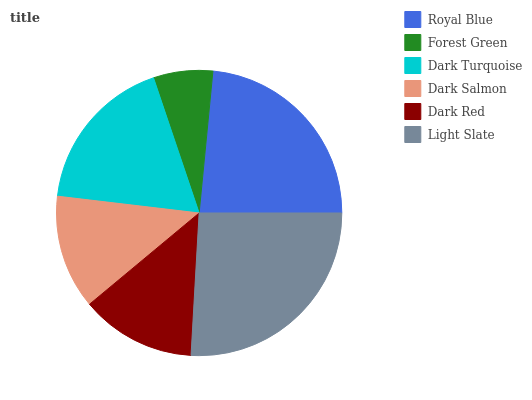Is Forest Green the minimum?
Answer yes or no. Yes. Is Light Slate the maximum?
Answer yes or no. Yes. Is Dark Turquoise the minimum?
Answer yes or no. No. Is Dark Turquoise the maximum?
Answer yes or no. No. Is Dark Turquoise greater than Forest Green?
Answer yes or no. Yes. Is Forest Green less than Dark Turquoise?
Answer yes or no. Yes. Is Forest Green greater than Dark Turquoise?
Answer yes or no. No. Is Dark Turquoise less than Forest Green?
Answer yes or no. No. Is Dark Turquoise the high median?
Answer yes or no. Yes. Is Dark Red the low median?
Answer yes or no. Yes. Is Light Slate the high median?
Answer yes or no. No. Is Dark Turquoise the low median?
Answer yes or no. No. 